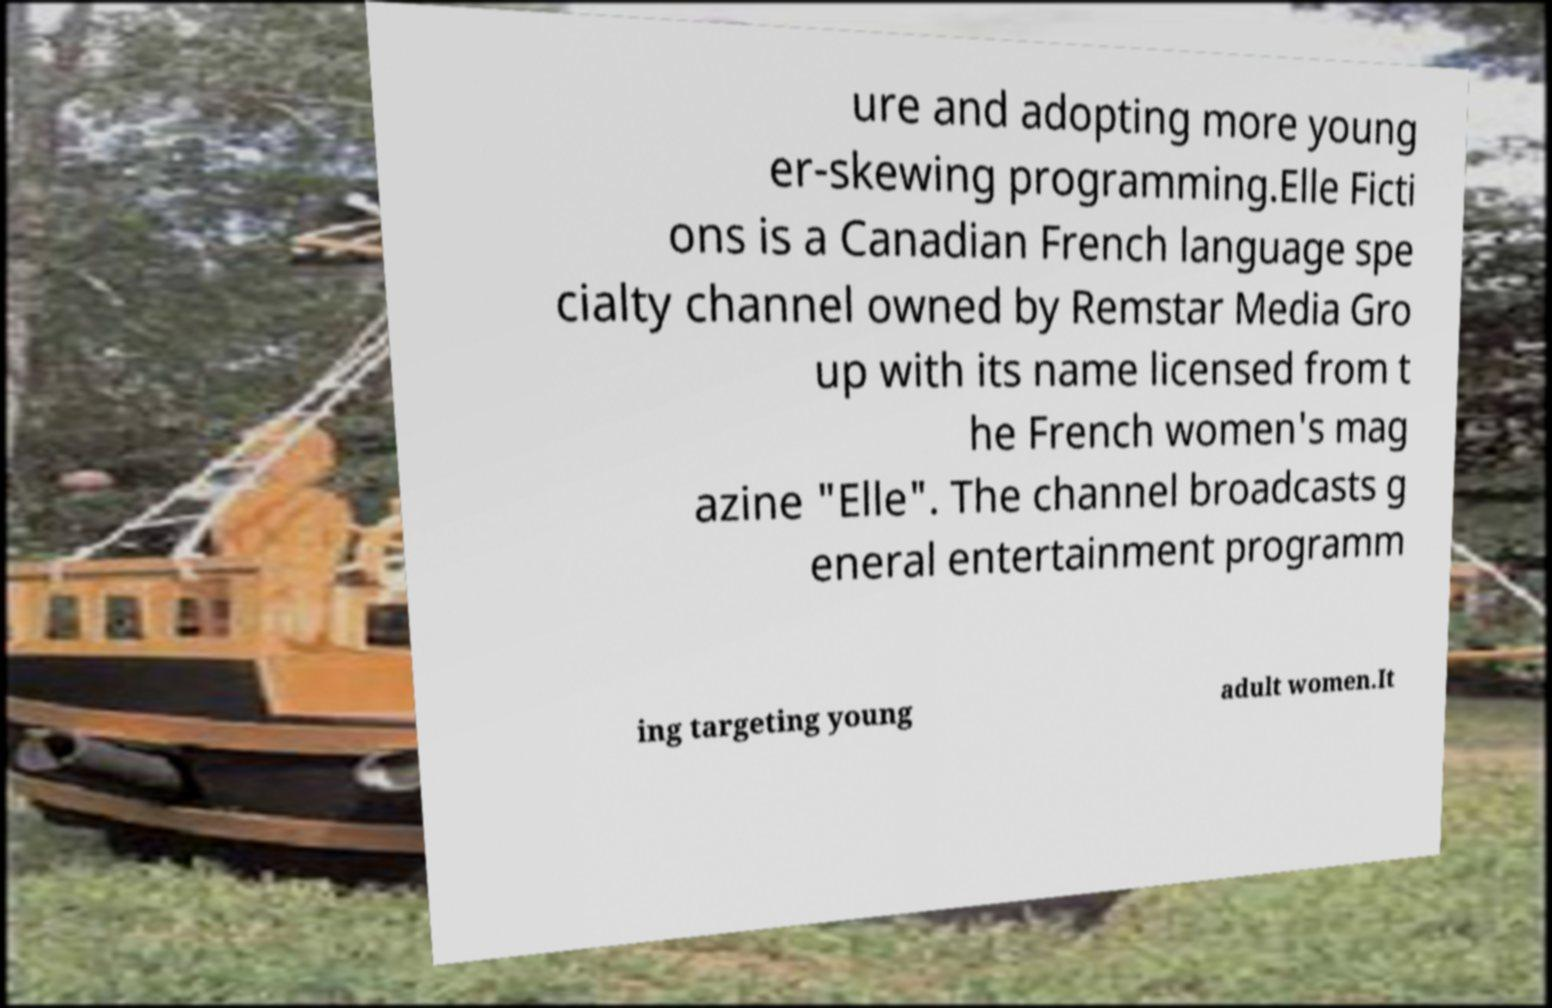Can you read and provide the text displayed in the image?This photo seems to have some interesting text. Can you extract and type it out for me? ure and adopting more young er-skewing programming.Elle Ficti ons is a Canadian French language spe cialty channel owned by Remstar Media Gro up with its name licensed from t he French women's mag azine "Elle". The channel broadcasts g eneral entertainment programm ing targeting young adult women.It 